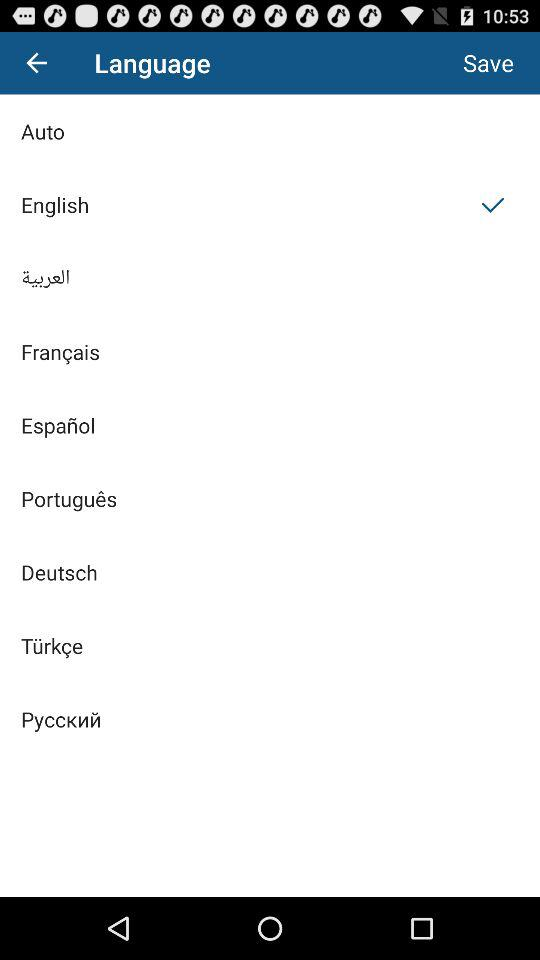Which language is selected? The selected language is English. 